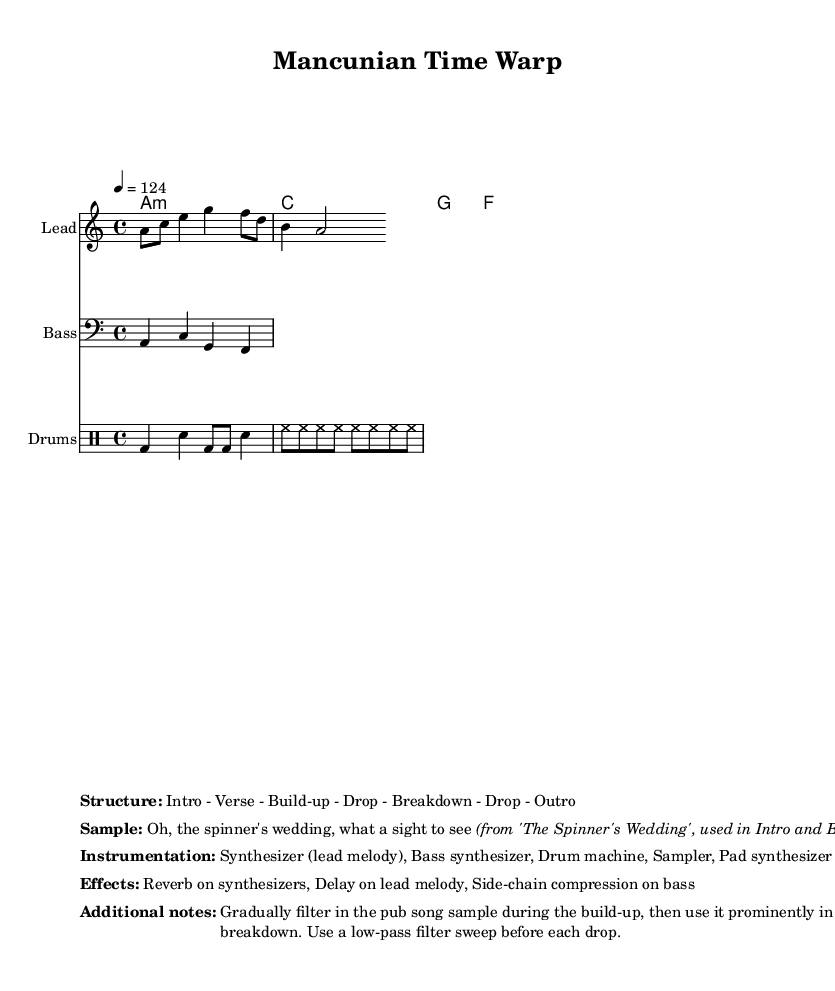What is the key signature of this music? The key signature is indicated by the "a" at the beginning, indicating that it is in the key of A minor, which has no sharps or flats.
Answer: A minor What is the time signature of this music? The time signature is shown with the "4/4" notation, which means there are four beats in each measure.
Answer: 4/4 What is the tempo of this music? The tempo is indicated as "4 = 124," meaning there are 124 beats per minute.
Answer: 124 BPM How many sections are in the structure of this track? The structure is described as "Intro - Verse - Build-up - Drop - Breakdown - Drop - Outro," which counts to a total of seven distinct sections.
Answer: 7 What is the primary sample used in the track? The sample mentioned is “Oh, the spinner's wedding, what a sight to see," which is quoted from 'The Spinner's Wedding.'
Answer: The Spinner's Wedding What instruments are primarily used in this track? The instrumentation includes "Synthesizer (lead melody), Bass synthesizer, Drum machine, Sampler, Pad synthesizer." By naming these, you can identify what creates the music's overall sound.
Answer: Synthesizer, Bass synthesizer, Drum machine, Sampler, Pad synthesizer What musical effects are applied in this track? The effects listed are "Reverb on synthesizers, Delay on lead melody, Side-chain compression on bass," indicating the processing used to modify how the music sounds.
Answer: Reverb, Delay, Side-chain compression 